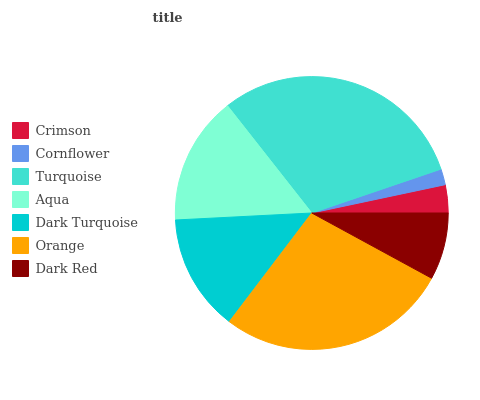Is Cornflower the minimum?
Answer yes or no. Yes. Is Turquoise the maximum?
Answer yes or no. Yes. Is Turquoise the minimum?
Answer yes or no. No. Is Cornflower the maximum?
Answer yes or no. No. Is Turquoise greater than Cornflower?
Answer yes or no. Yes. Is Cornflower less than Turquoise?
Answer yes or no. Yes. Is Cornflower greater than Turquoise?
Answer yes or no. No. Is Turquoise less than Cornflower?
Answer yes or no. No. Is Dark Turquoise the high median?
Answer yes or no. Yes. Is Dark Turquoise the low median?
Answer yes or no. Yes. Is Orange the high median?
Answer yes or no. No. Is Turquoise the low median?
Answer yes or no. No. 